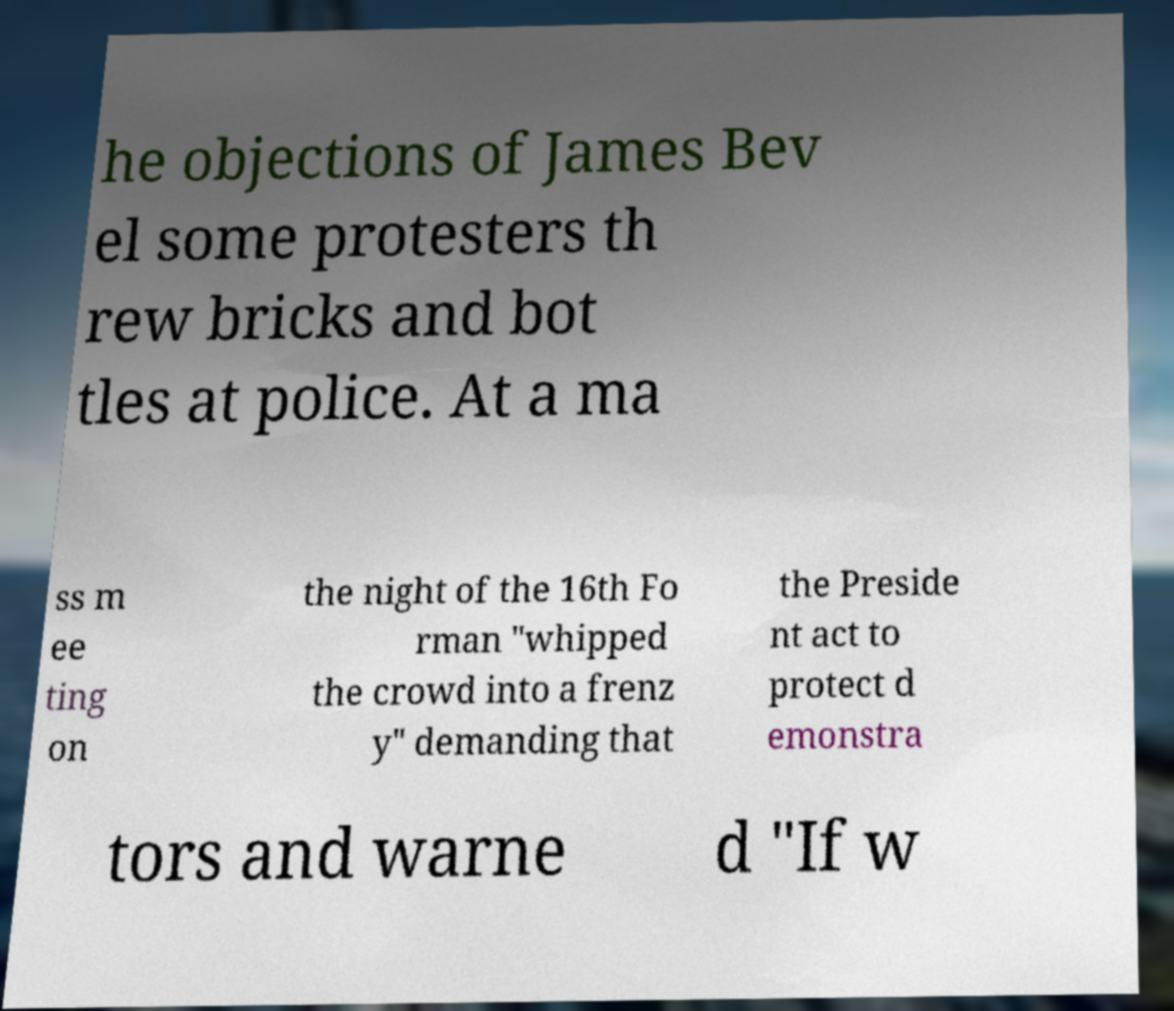Could you extract and type out the text from this image? he objections of James Bev el some protesters th rew bricks and bot tles at police. At a ma ss m ee ting on the night of the 16th Fo rman "whipped the crowd into a frenz y" demanding that the Preside nt act to protect d emonstra tors and warne d "If w 